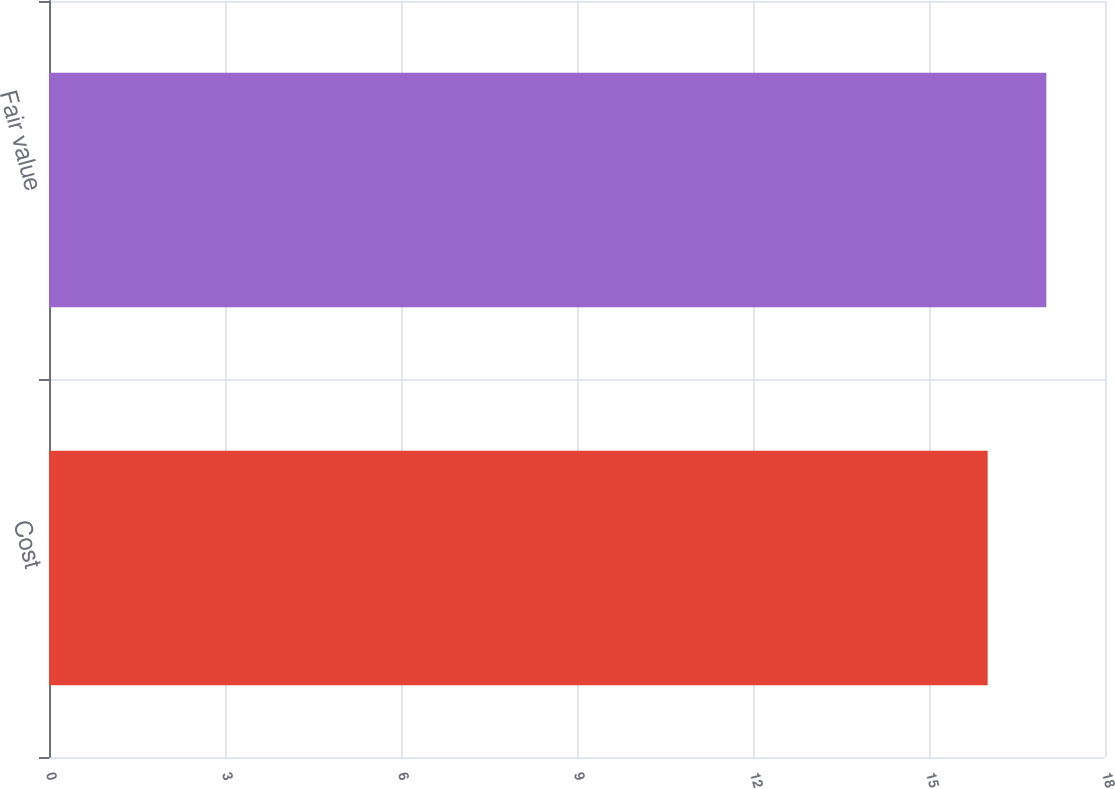Convert chart to OTSL. <chart><loc_0><loc_0><loc_500><loc_500><bar_chart><fcel>Cost<fcel>Fair value<nl><fcel>16<fcel>17<nl></chart> 